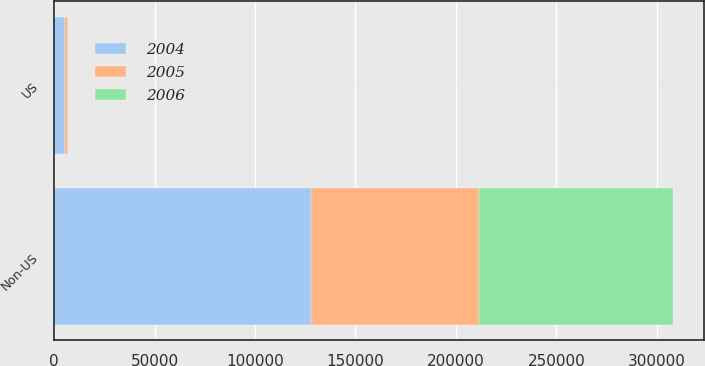Convert chart. <chart><loc_0><loc_0><loc_500><loc_500><stacked_bar_chart><ecel><fcel>US<fcel>Non-US<nl><fcel>2004<fcel>5472<fcel>127922<nl><fcel>2006<fcel>54<fcel>96680<nl><fcel>2005<fcel>1290<fcel>83378<nl></chart> 